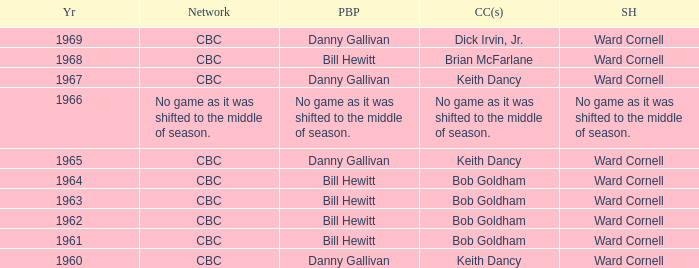Who did the play-by-play with studio host Ward Cornell and color commentator Bob Goldham? Bill Hewitt, Bill Hewitt, Bill Hewitt, Bill Hewitt. 